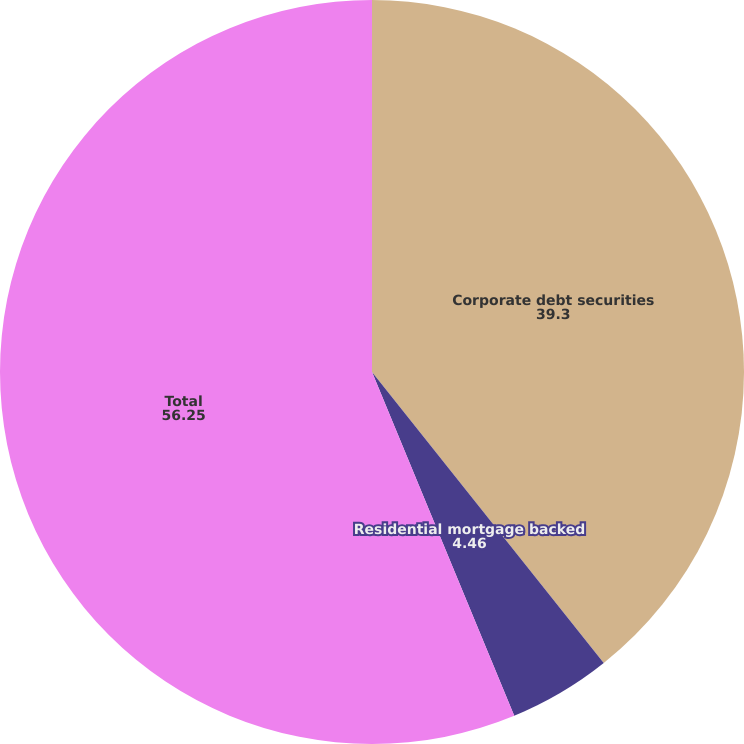<chart> <loc_0><loc_0><loc_500><loc_500><pie_chart><fcel>Corporate debt securities<fcel>Residential mortgage backed<fcel>Total<nl><fcel>39.3%<fcel>4.46%<fcel>56.25%<nl></chart> 